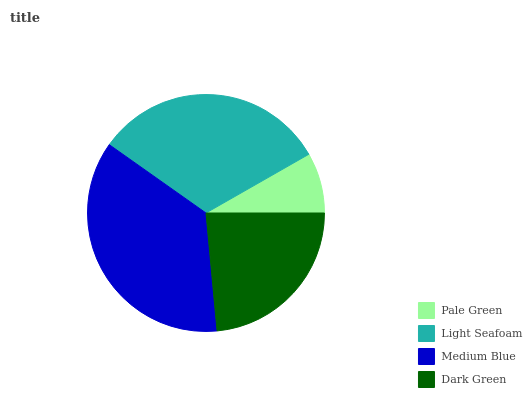Is Pale Green the minimum?
Answer yes or no. Yes. Is Medium Blue the maximum?
Answer yes or no. Yes. Is Light Seafoam the minimum?
Answer yes or no. No. Is Light Seafoam the maximum?
Answer yes or no. No. Is Light Seafoam greater than Pale Green?
Answer yes or no. Yes. Is Pale Green less than Light Seafoam?
Answer yes or no. Yes. Is Pale Green greater than Light Seafoam?
Answer yes or no. No. Is Light Seafoam less than Pale Green?
Answer yes or no. No. Is Light Seafoam the high median?
Answer yes or no. Yes. Is Dark Green the low median?
Answer yes or no. Yes. Is Dark Green the high median?
Answer yes or no. No. Is Light Seafoam the low median?
Answer yes or no. No. 